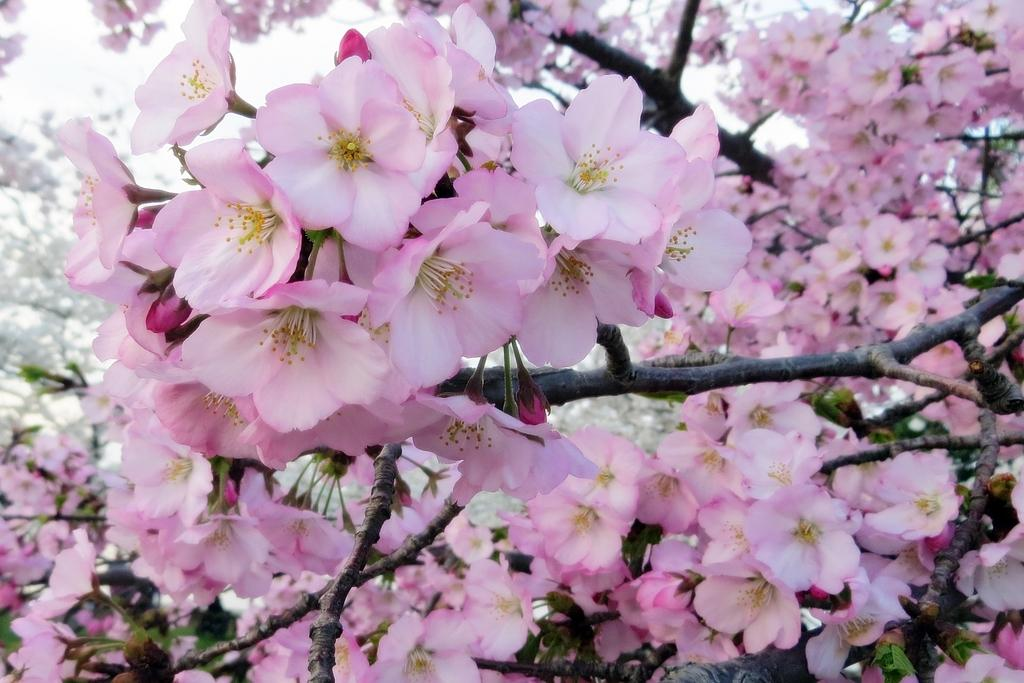What type of plant can be seen on the branches of the tree in the image? There are flowers on the branches of the tree in the image. What type of knee can be seen on the tree in the image? There is no knee present in the image; it features a tree with flowers on its branches. 